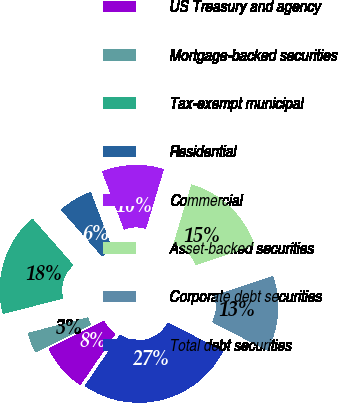Convert chart. <chart><loc_0><loc_0><loc_500><loc_500><pie_chart><fcel>US Treasury and agency<fcel>Mortgage-backed securities<fcel>Tax-exempt municipal<fcel>Residential<fcel>Commercial<fcel>Asset-backed securities<fcel>Corporate debt securities<fcel>Total debt securities<nl><fcel>8.08%<fcel>3.37%<fcel>17.51%<fcel>5.72%<fcel>10.44%<fcel>15.15%<fcel>12.79%<fcel>26.94%<nl></chart> 